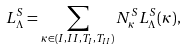Convert formula to latex. <formula><loc_0><loc_0><loc_500><loc_500>L _ { \Lambda } ^ { S } = \sum _ { \kappa \in ( I , I I , T _ { I } , T _ { I I } ) } N _ { \kappa } ^ { S } L _ { \Lambda } ^ { S } ( \kappa ) ,</formula> 